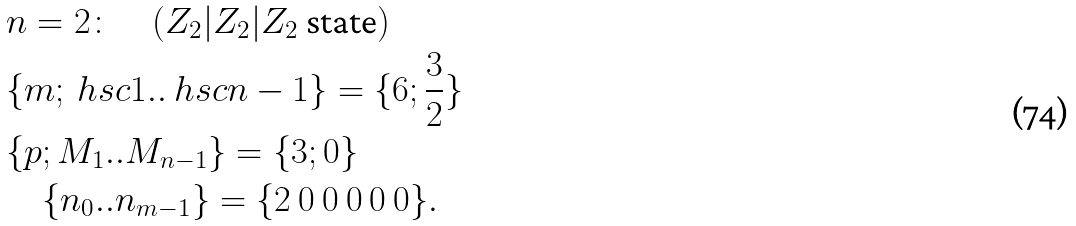<formula> <loc_0><loc_0><loc_500><loc_500>& n = 2 \colon \quad ( Z _ { 2 } | Z _ { 2 } | Z _ { 2 } \text { state} ) \\ & \{ m ; \ h s c { 1 } . . \ h s c { n - 1 } \} = \{ 6 ; \frac { 3 } { 2 } \} \\ & \{ p ; M _ { 1 } . . M _ { n - 1 } \} = \{ 3 ; 0 \} \\ & \quad \{ n _ { 0 } . . n _ { m - 1 } \} = \{ 2 \ 0 \ 0 \ 0 \ 0 \ 0 \} .</formula> 